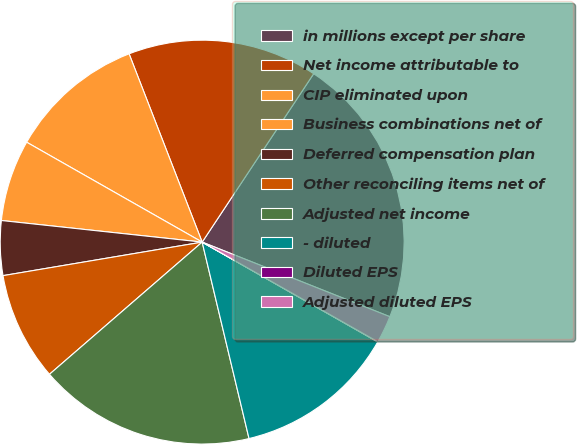Convert chart to OTSL. <chart><loc_0><loc_0><loc_500><loc_500><pie_chart><fcel>in millions except per share<fcel>Net income attributable to<fcel>CIP eliminated upon<fcel>Business combinations net of<fcel>Deferred compensation plan<fcel>Other reconciling items net of<fcel>Adjusted net income<fcel>- diluted<fcel>Diluted EPS<fcel>Adjusted diluted EPS<nl><fcel>21.71%<fcel>15.2%<fcel>10.87%<fcel>6.53%<fcel>4.36%<fcel>8.7%<fcel>17.37%<fcel>13.04%<fcel>0.02%<fcel>2.19%<nl></chart> 